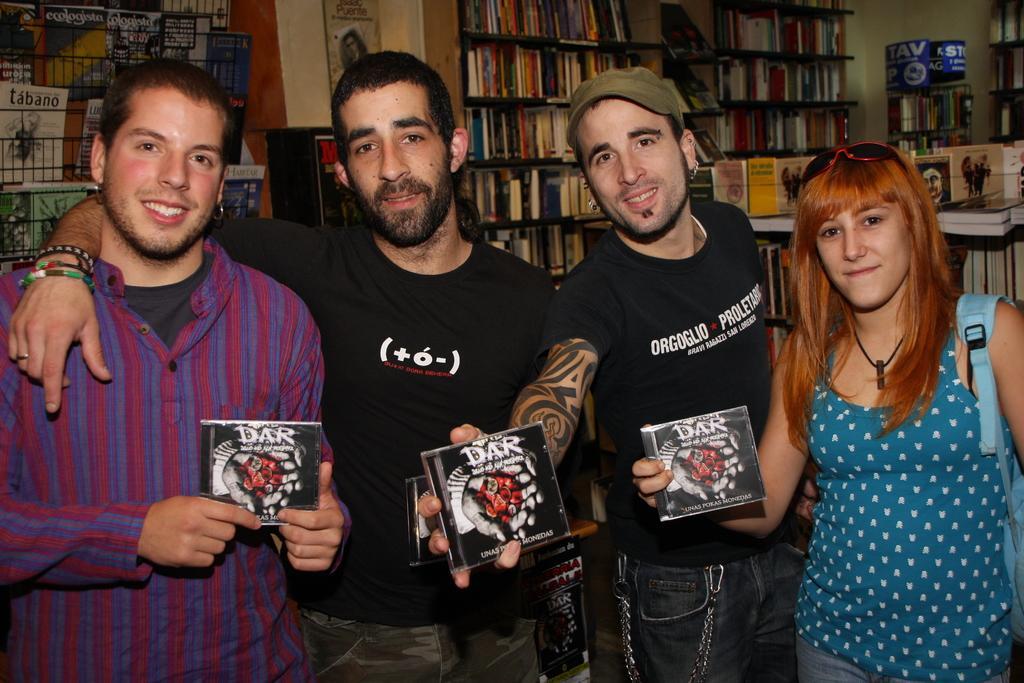How would you summarize this image in a sentence or two? In the image there are three men and a woman standing in the front holding a book and behind them there are racks with many books all over it. 